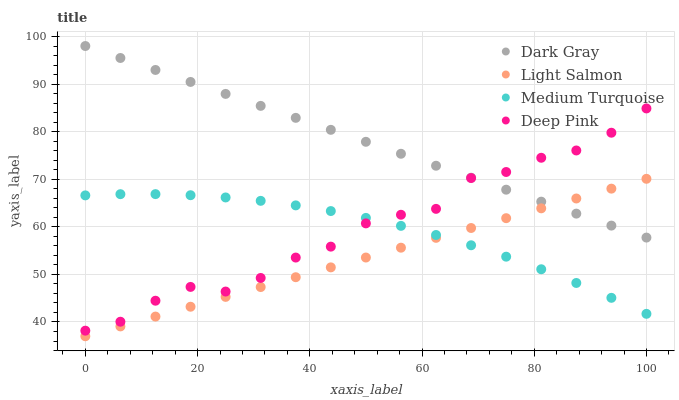Does Light Salmon have the minimum area under the curve?
Answer yes or no. Yes. Does Dark Gray have the maximum area under the curve?
Answer yes or no. Yes. Does Deep Pink have the minimum area under the curve?
Answer yes or no. No. Does Deep Pink have the maximum area under the curve?
Answer yes or no. No. Is Light Salmon the smoothest?
Answer yes or no. Yes. Is Deep Pink the roughest?
Answer yes or no. Yes. Is Deep Pink the smoothest?
Answer yes or no. No. Is Light Salmon the roughest?
Answer yes or no. No. Does Light Salmon have the lowest value?
Answer yes or no. Yes. Does Deep Pink have the lowest value?
Answer yes or no. No. Does Dark Gray have the highest value?
Answer yes or no. Yes. Does Light Salmon have the highest value?
Answer yes or no. No. Is Medium Turquoise less than Dark Gray?
Answer yes or no. Yes. Is Deep Pink greater than Light Salmon?
Answer yes or no. Yes. Does Light Salmon intersect Medium Turquoise?
Answer yes or no. Yes. Is Light Salmon less than Medium Turquoise?
Answer yes or no. No. Is Light Salmon greater than Medium Turquoise?
Answer yes or no. No. Does Medium Turquoise intersect Dark Gray?
Answer yes or no. No. 